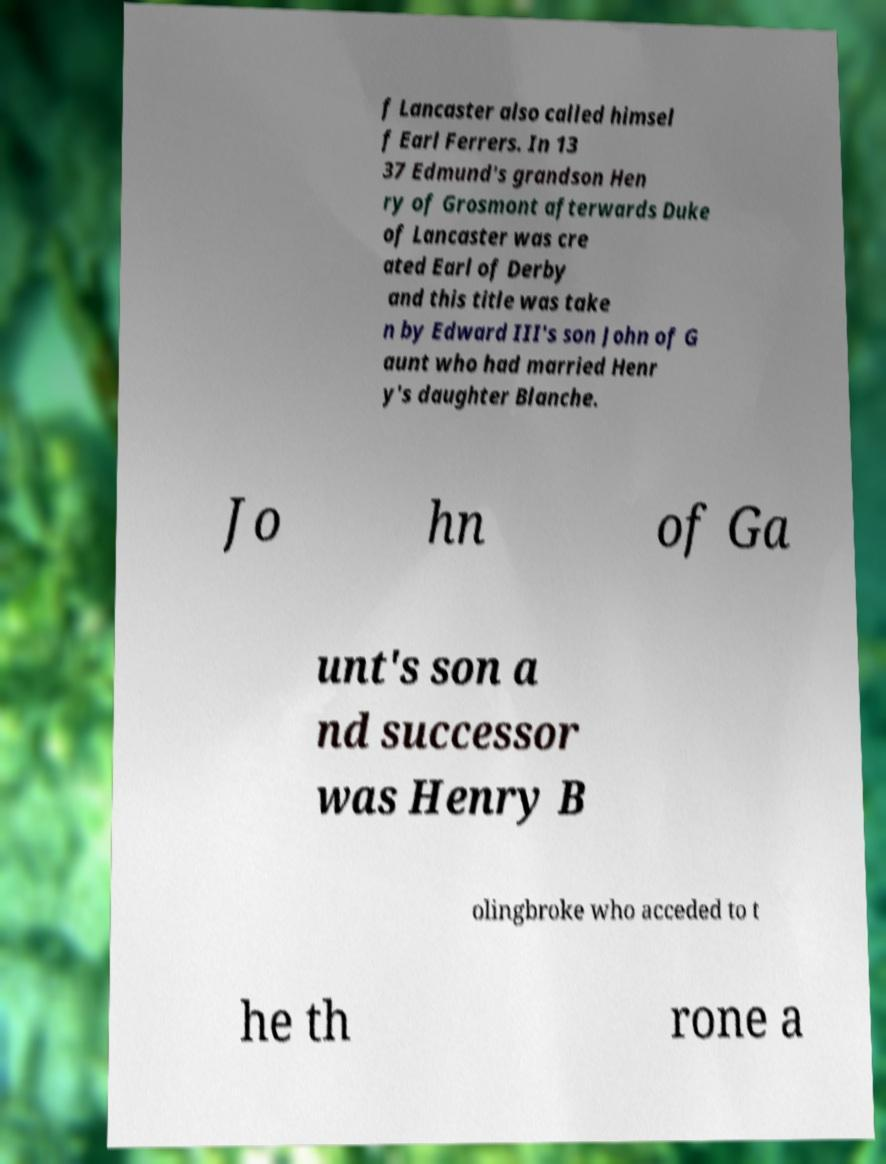Can you accurately transcribe the text from the provided image for me? f Lancaster also called himsel f Earl Ferrers. In 13 37 Edmund's grandson Hen ry of Grosmont afterwards Duke of Lancaster was cre ated Earl of Derby and this title was take n by Edward III's son John of G aunt who had married Henr y's daughter Blanche. Jo hn of Ga unt's son a nd successor was Henry B olingbroke who acceded to t he th rone a 